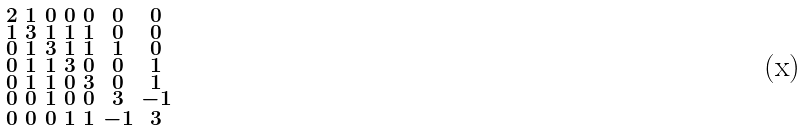<formula> <loc_0><loc_0><loc_500><loc_500>\begin{smallmatrix} 2 & 1 & 0 & 0 & 0 & 0 & 0 \\ 1 & 3 & 1 & 1 & 1 & 0 & 0 \\ 0 & 1 & 3 & 1 & 1 & 1 & 0 \\ 0 & 1 & 1 & 3 & 0 & 0 & 1 \\ 0 & 1 & 1 & 0 & 3 & 0 & 1 \\ 0 & 0 & 1 & 0 & 0 & 3 & - 1 \\ 0 & 0 & 0 & 1 & 1 & - 1 & 3 \end{smallmatrix}</formula> 